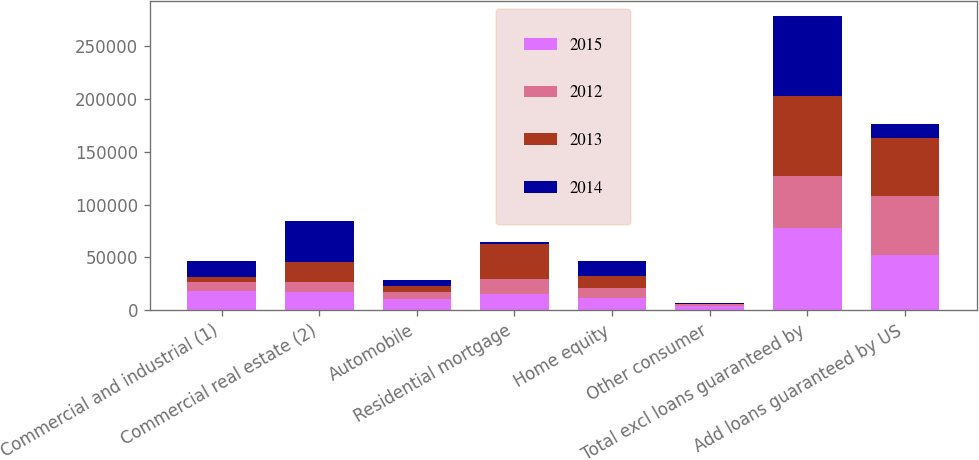Convert chart. <chart><loc_0><loc_0><loc_500><loc_500><stacked_bar_chart><ecel><fcel>Commercial and industrial (1)<fcel>Commercial real estate (2)<fcel>Automobile<fcel>Residential mortgage<fcel>Home equity<fcel>Other consumer<fcel>Total excl loans guaranteed by<fcel>Add loans guaranteed by US<nl><fcel>2015<fcel>18148<fcel>17215<fcel>10182<fcel>15074<fcel>11508<fcel>3895<fcel>77484<fcel>51878<nl><fcel>2012<fcel>8724<fcel>9549<fcel>7162<fcel>14082<fcel>9044<fcel>1394<fcel>49955<fcel>55835<nl><fcel>2013<fcel>4937<fcel>18793<fcel>5703<fcel>33040<fcel>12159<fcel>837<fcel>75469<fcel>55012<nl><fcel>2014<fcel>14562<fcel>39142<fcel>5055<fcel>2469<fcel>13983<fcel>998<fcel>76209<fcel>13983<nl></chart> 